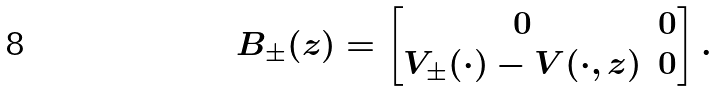Convert formula to latex. <formula><loc_0><loc_0><loc_500><loc_500>B _ { \pm } ( z ) = \begin{bmatrix} 0 & 0 \\ V _ { \pm } ( \cdot ) - V ( \cdot , z ) & 0 \end{bmatrix} .</formula> 